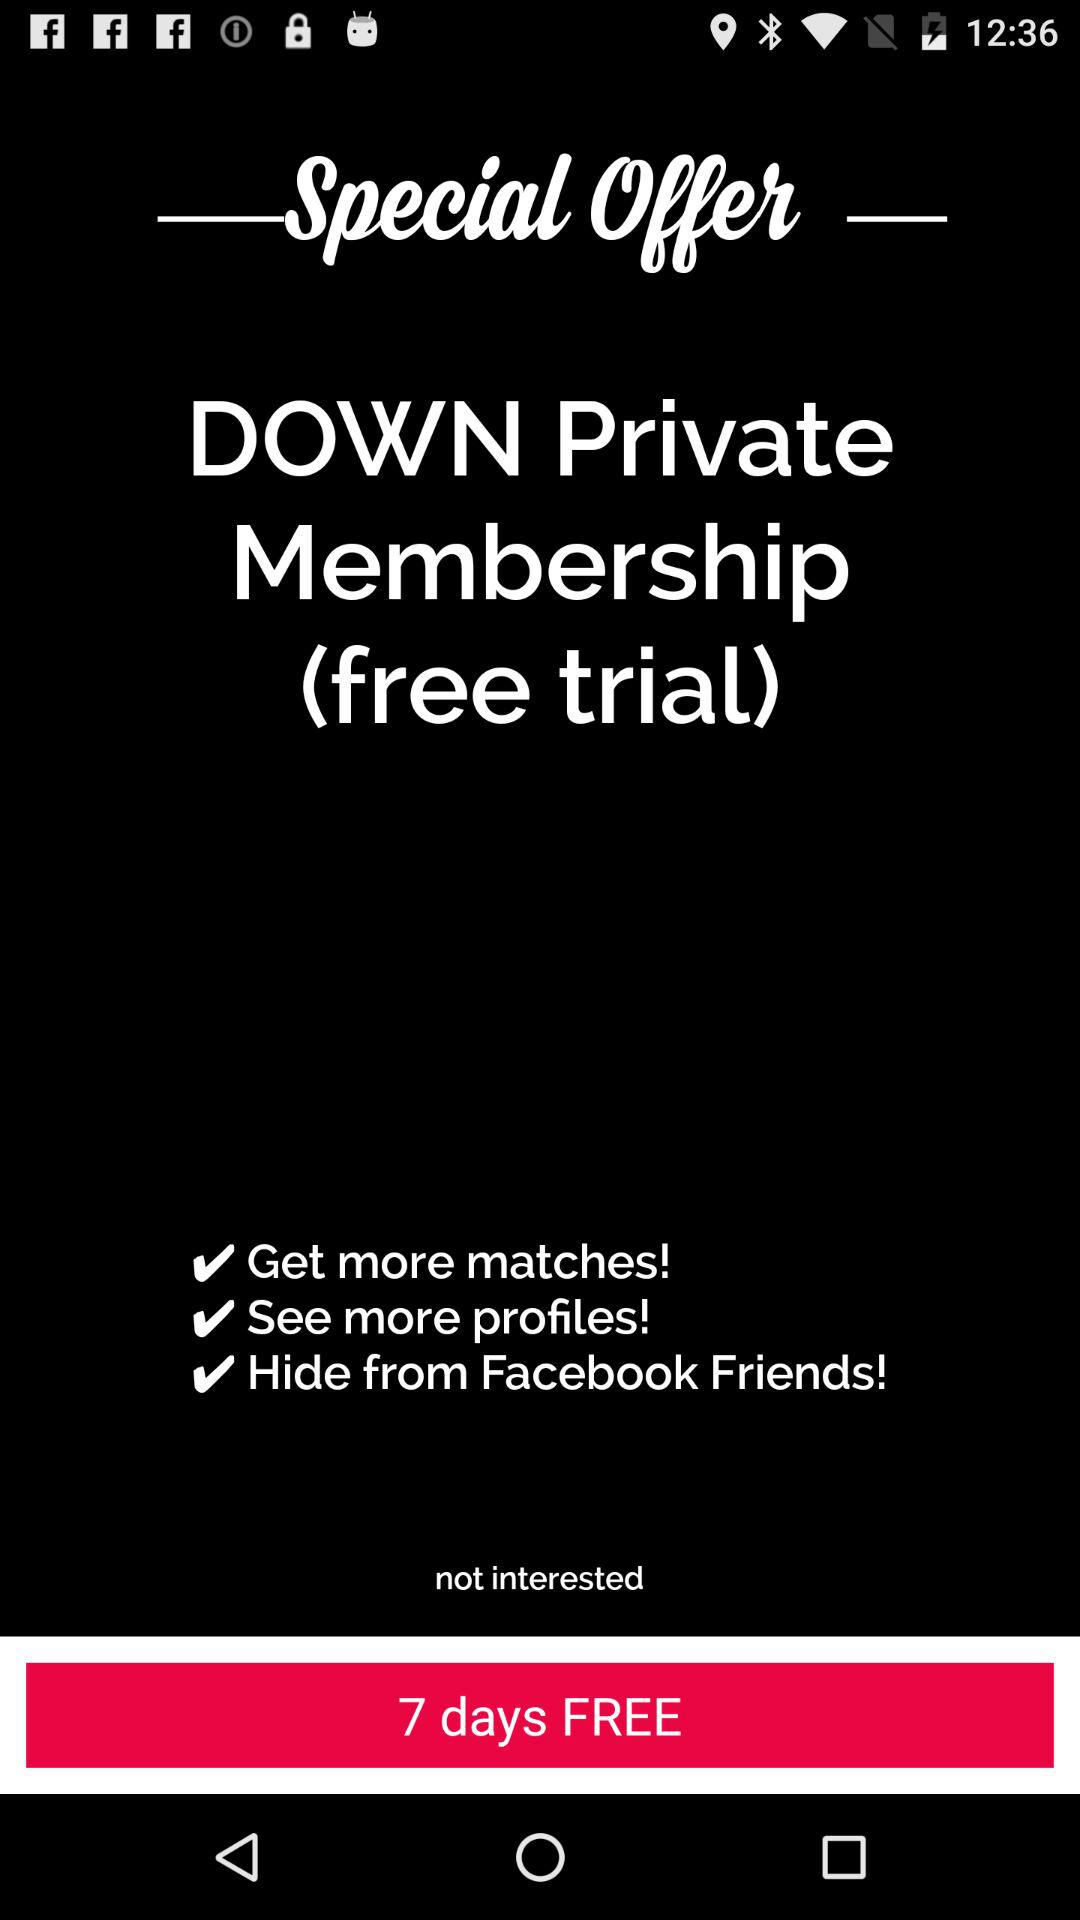For how many days are we getting the free trial? You are getting the free trial for 7 days. 